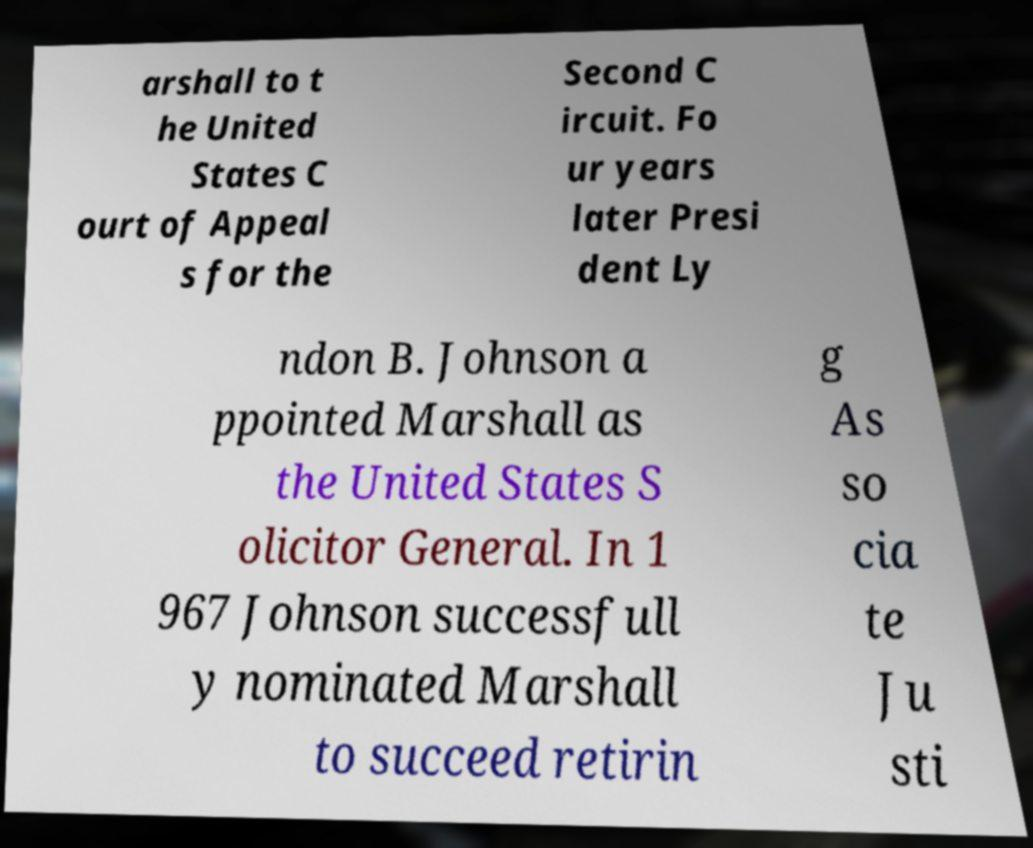Can you accurately transcribe the text from the provided image for me? arshall to t he United States C ourt of Appeal s for the Second C ircuit. Fo ur years later Presi dent Ly ndon B. Johnson a ppointed Marshall as the United States S olicitor General. In 1 967 Johnson successfull y nominated Marshall to succeed retirin g As so cia te Ju sti 